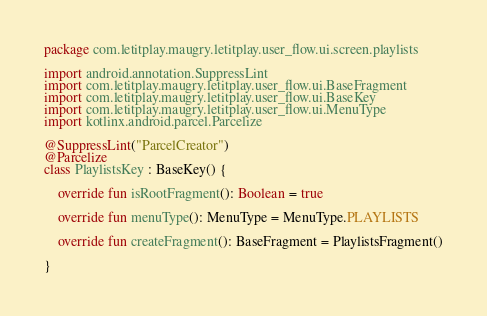Convert code to text. <code><loc_0><loc_0><loc_500><loc_500><_Kotlin_>package com.letitplay.maugry.letitplay.user_flow.ui.screen.playlists

import android.annotation.SuppressLint
import com.letitplay.maugry.letitplay.user_flow.ui.BaseFragment
import com.letitplay.maugry.letitplay.user_flow.ui.BaseKey
import com.letitplay.maugry.letitplay.user_flow.ui.MenuType
import kotlinx.android.parcel.Parcelize

@SuppressLint("ParcelCreator")
@Parcelize
class PlaylistsKey : BaseKey() {

    override fun isRootFragment(): Boolean = true

    override fun menuType(): MenuType = MenuType.PLAYLISTS

    override fun createFragment(): BaseFragment = PlaylistsFragment()

}</code> 